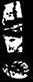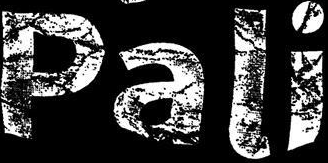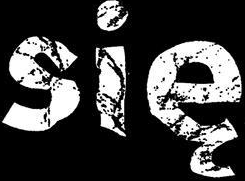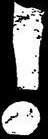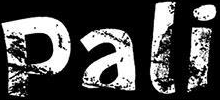What words are shown in these images in order, separated by a semicolon? !; Pali; się; !; Pali 